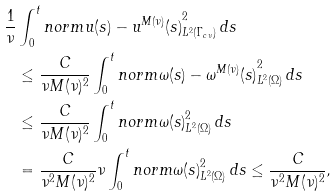Convert formula to latex. <formula><loc_0><loc_0><loc_500><loc_500>\frac { 1 } { \nu } & \int _ { 0 } ^ { t } n o r m { u ( s ) - u ^ { M ( \nu ) } ( s ) } _ { L ^ { 2 } ( \Gamma _ { c \nu } ) } ^ { 2 } \, d s \\ & \leq \frac { C } { \nu M ( \nu ) ^ { 2 } } \int _ { 0 } ^ { t } n o r m { \omega ( s ) - \omega ^ { M ( \nu ) } ( s ) } _ { L ^ { 2 } ( \Omega ) } ^ { 2 } \, d s \\ & \leq \frac { C } { \nu M ( \nu ) ^ { 2 } } \int _ { 0 } ^ { t } n o r m { \omega ( s ) } _ { L ^ { 2 } ( \Omega ) } ^ { 2 } \, d s \\ & = \frac { C } { \nu ^ { 2 } M ( \nu ) ^ { 2 } } \nu \int _ { 0 } ^ { t } n o r m { \omega ( s ) } _ { L ^ { 2 } ( \Omega ) } ^ { 2 } \, d s \leq \frac { C } { \nu ^ { 2 } M ( \nu ) ^ { 2 } } ,</formula> 